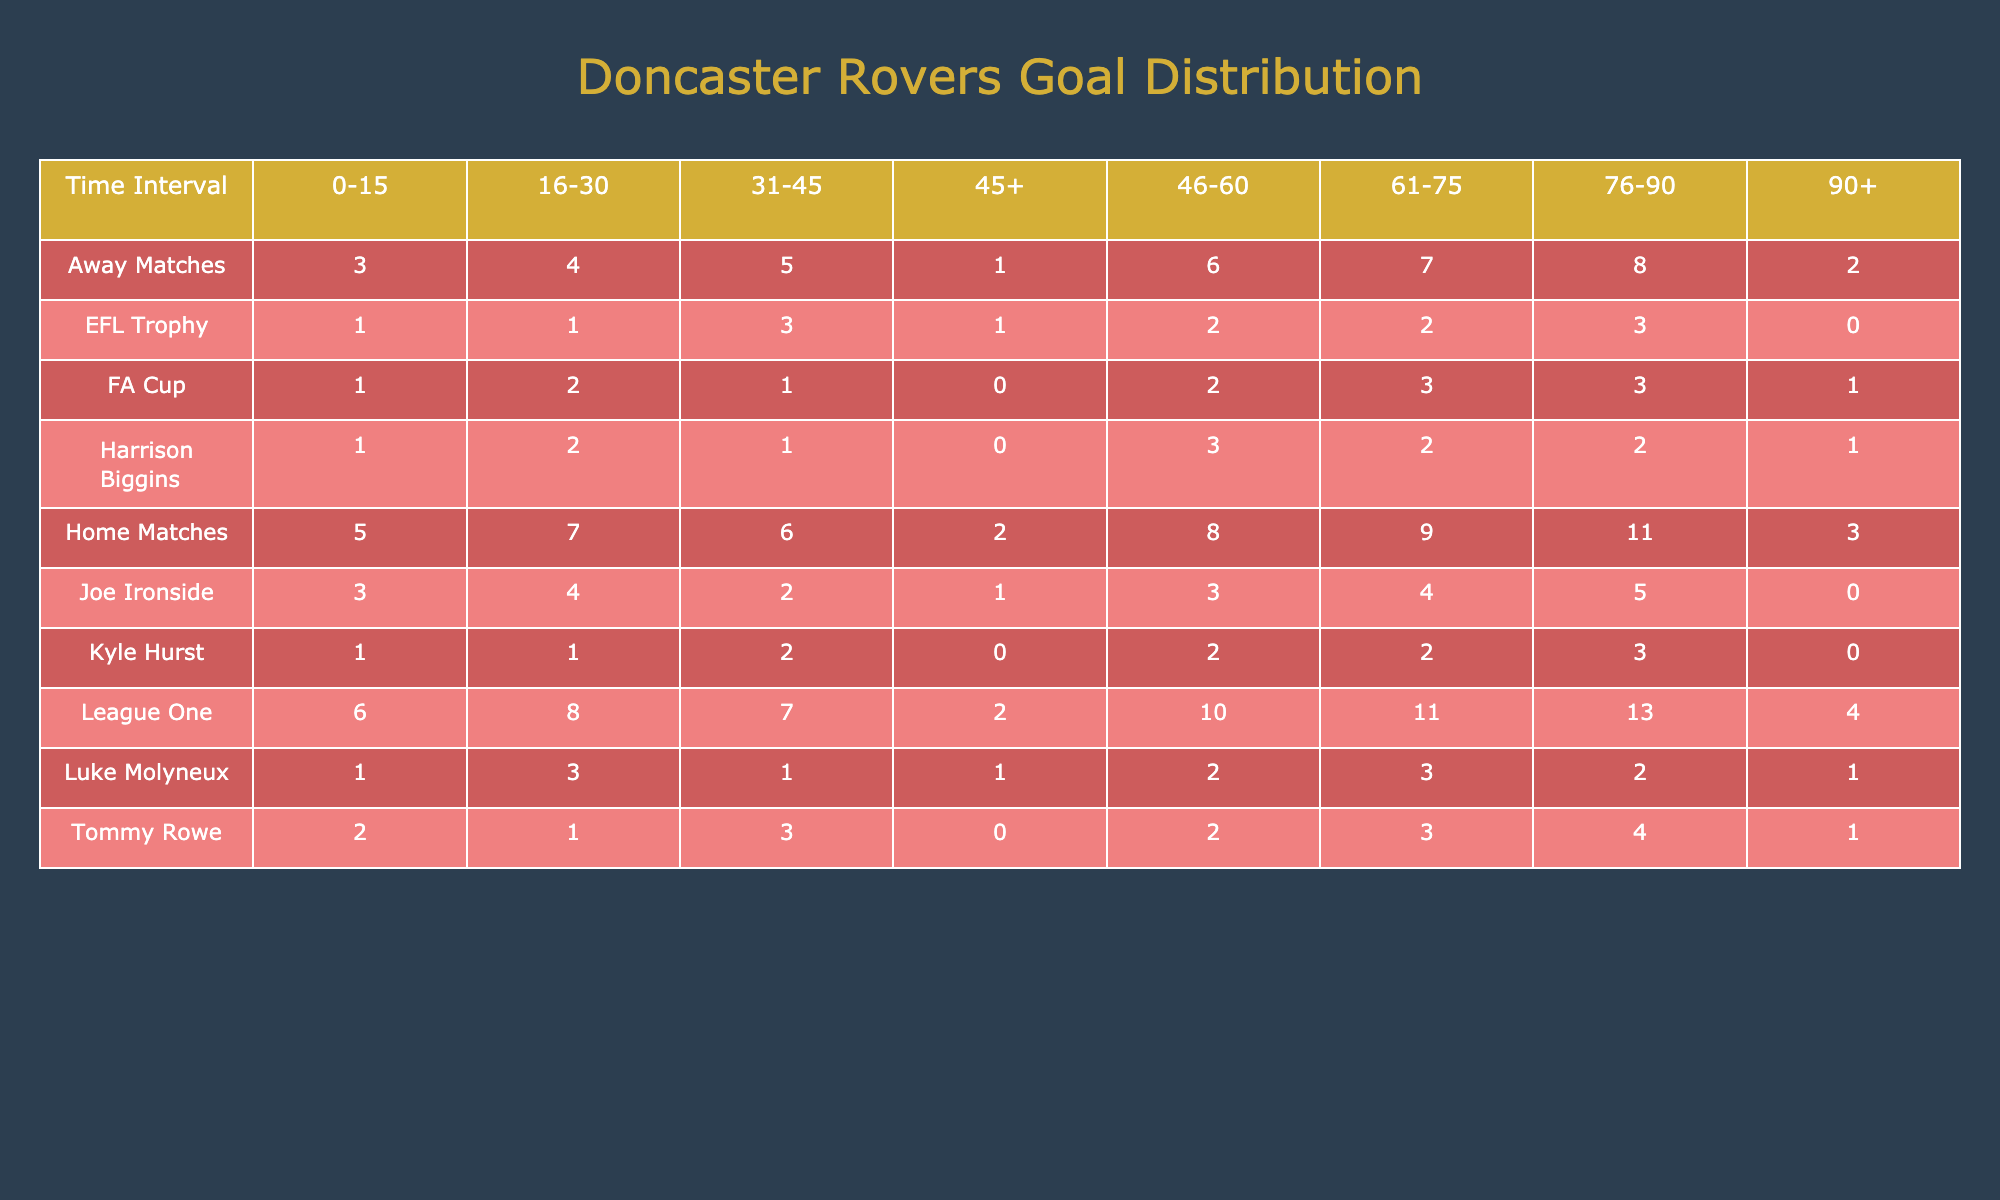What is the total number of goals scored by Doncaster Rovers in the time interval of 76-90 minutes during home matches? In home matches, the goals scored in the 76-90 minutes interval are 11.
Answer: 11 How many goals did Doncaster Rovers score in the FA Cup in the 46-60 minutes interval? In the FA Cup section, the number of goals scored in the 46-60 minutes interval is 2.
Answer: 2 Which time interval had the highest number of goals scored in away matches? To find the highest number of goals in away matches, we look across all time intervals: 3 (0-15), 4 (16-30), 5 (31-45), 1 (45+), 6 (46-60), 7 (61-75), 8 (76-90), 2 (90+). The highest is 8 goals in the 76-90 minutes interval.
Answer: 8 What is the average number of goals scored by Doncaster Rovers in the League One during the 0-15 minutes interval? In League One, the number of goals scored in the 0-15 minutes interval is 6. Since there's only one value, the average is 6.
Answer: 6 Did Joe Ironside score more goals in the 61-75 minutes interval than in the 31-45 minutes interval? Joe Ironside scored 4 goals in the 61-75 minutes interval and 2 goals in the 31-45 minutes interval. Since 4 is greater than 2, the statement is true.
Answer: Yes What is the total number of goals scored across all matches in the 45+ time interval? Adding the goals for 45+ minutes from all match types: Home (2) + Away (1) + League One (2) + FA Cup (0) + EFL Trophy (1) = 6.
Answer: 6 Which time interval has the lowest goals scored in the EFL Trophy? In the EFL Trophy, the number of goals per time interval are as follows: 1 (0-15), 1 (16-30), 3 (31-45), 1 (45+), 2 (46-60), 2 (61-75), 3 (76-90), 0 (90+). The lowest is 0 goals in the 90+ interval.
Answer: 90+ What is the difference in goals scored between the 31-45 and 46-60 minutes intervals in home matches? In home matches, the goals scored are: 31-45 = 6 and 46-60 = 8. The difference is 8 - 6 = 2.
Answer: 2 Did Tommy Rowe score more goals overall than Harrison Biggins? Combining all intervals, Tommy Rowe scores: 2 + 1 + 3 + 0 + 2 + 3 + 4 + 1 = 16. Harrison Biggins scores: 1 + 2 + 1 + 0 + 3 + 2 + 2 + 1 = 12. Since 16 > 12, the statement is true.
Answer: Yes What percentage of goals did Doncaster Rovers score in the 76-90 minutes interval compared to the total goals scored across all time intervals? First, calculate the total goals across the table: sum all values, which equals 101. Goals in 76-90 are 11 (home) + 8 (away) + 13 (League One) + 3 (FA Cup) + 3 (EFL Trophy) + 4 (Tommy Rowe) + 5 (Joe Ironside) + 2 (Harrison Biggins) + 3 (Kyle Hurst) + 2 (Luke Molyneux) = 68. So, the percentage is (68/101) * 100 ≈ 67.32%.
Answer: ≈ 67.32% 